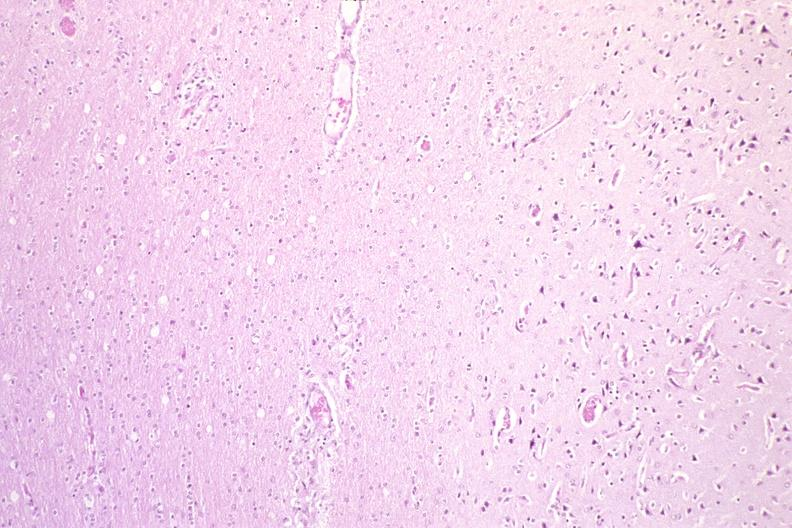does this image show brain, hiv neuropathy?
Answer the question using a single word or phrase. Yes 